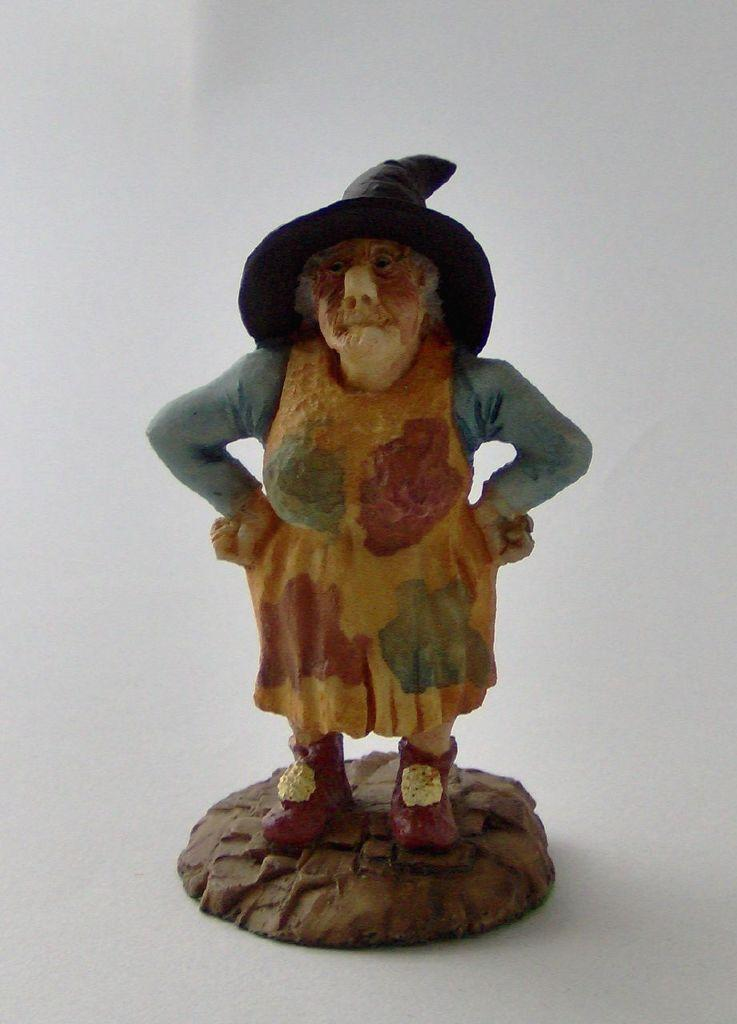What is the main subject in the middle of the image? There is a small statue in the middle of the image. What color is the background of the image? The background of the image is white. What type of stick can be seen in the image? There is no stick present in the image. What is the texture of the statue in the image? The provided facts do not give information about the texture of the statue, so it cannot be determined from the image. 